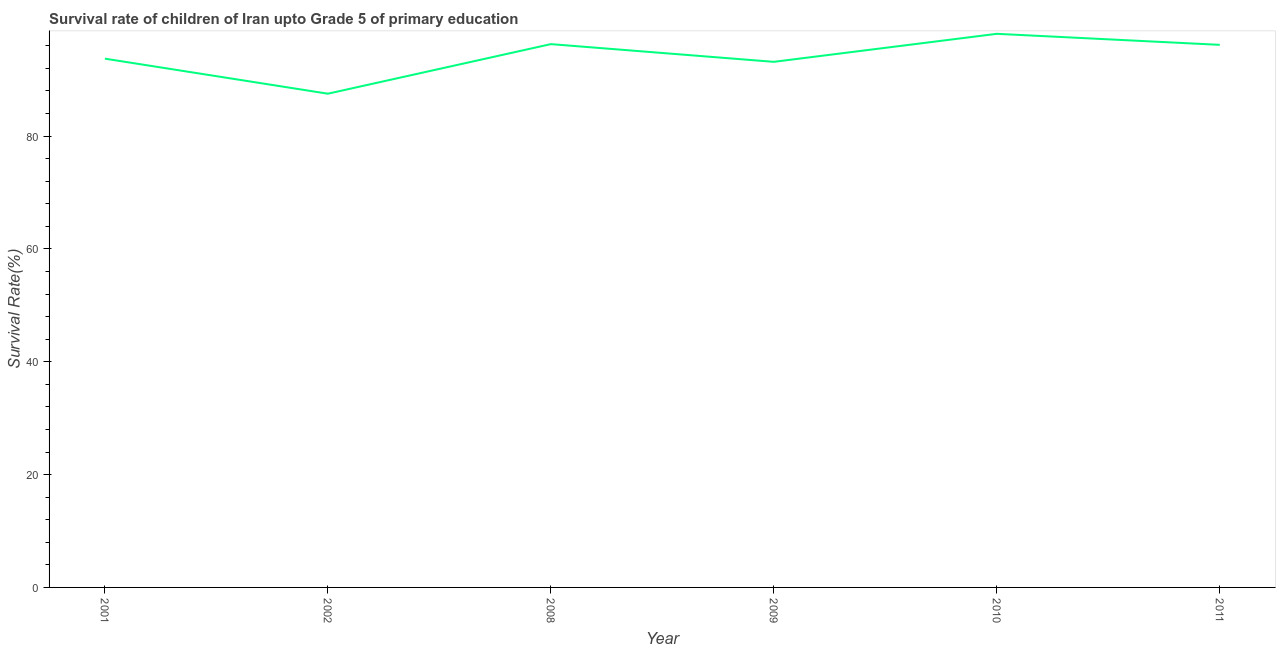What is the survival rate in 2009?
Your answer should be compact. 93.16. Across all years, what is the maximum survival rate?
Offer a terse response. 98.13. Across all years, what is the minimum survival rate?
Ensure brevity in your answer.  87.52. In which year was the survival rate maximum?
Offer a terse response. 2010. What is the sum of the survival rate?
Your answer should be compact. 565.02. What is the difference between the survival rate in 2008 and 2010?
Offer a very short reply. -1.83. What is the average survival rate per year?
Provide a succinct answer. 94.17. What is the median survival rate?
Offer a terse response. 94.95. Do a majority of the years between 2001 and 2008 (inclusive) have survival rate greater than 28 %?
Give a very brief answer. Yes. What is the ratio of the survival rate in 2008 to that in 2011?
Provide a succinct answer. 1. What is the difference between the highest and the second highest survival rate?
Your response must be concise. 1.83. Is the sum of the survival rate in 2009 and 2010 greater than the maximum survival rate across all years?
Make the answer very short. Yes. What is the difference between the highest and the lowest survival rate?
Offer a very short reply. 10.61. In how many years, is the survival rate greater than the average survival rate taken over all years?
Make the answer very short. 3. Does the survival rate monotonically increase over the years?
Give a very brief answer. No. How many lines are there?
Make the answer very short. 1. What is the difference between two consecutive major ticks on the Y-axis?
Your answer should be compact. 20. Are the values on the major ticks of Y-axis written in scientific E-notation?
Your answer should be very brief. No. Does the graph contain any zero values?
Keep it short and to the point. No. Does the graph contain grids?
Give a very brief answer. No. What is the title of the graph?
Offer a very short reply. Survival rate of children of Iran upto Grade 5 of primary education. What is the label or title of the Y-axis?
Your answer should be very brief. Survival Rate(%). What is the Survival Rate(%) of 2001?
Offer a terse response. 93.73. What is the Survival Rate(%) of 2002?
Ensure brevity in your answer.  87.52. What is the Survival Rate(%) in 2008?
Your response must be concise. 96.3. What is the Survival Rate(%) of 2009?
Offer a terse response. 93.16. What is the Survival Rate(%) of 2010?
Provide a succinct answer. 98.13. What is the Survival Rate(%) in 2011?
Your answer should be compact. 96.18. What is the difference between the Survival Rate(%) in 2001 and 2002?
Your answer should be very brief. 6.21. What is the difference between the Survival Rate(%) in 2001 and 2008?
Your answer should be very brief. -2.57. What is the difference between the Survival Rate(%) in 2001 and 2009?
Ensure brevity in your answer.  0.57. What is the difference between the Survival Rate(%) in 2001 and 2010?
Your answer should be compact. -4.4. What is the difference between the Survival Rate(%) in 2001 and 2011?
Offer a very short reply. -2.45. What is the difference between the Survival Rate(%) in 2002 and 2008?
Your answer should be compact. -8.79. What is the difference between the Survival Rate(%) in 2002 and 2009?
Your answer should be very brief. -5.65. What is the difference between the Survival Rate(%) in 2002 and 2010?
Your answer should be compact. -10.61. What is the difference between the Survival Rate(%) in 2002 and 2011?
Offer a very short reply. -8.66. What is the difference between the Survival Rate(%) in 2008 and 2009?
Your response must be concise. 3.14. What is the difference between the Survival Rate(%) in 2008 and 2010?
Offer a very short reply. -1.83. What is the difference between the Survival Rate(%) in 2008 and 2011?
Provide a short and direct response. 0.13. What is the difference between the Survival Rate(%) in 2009 and 2010?
Your response must be concise. -4.97. What is the difference between the Survival Rate(%) in 2009 and 2011?
Provide a succinct answer. -3.01. What is the difference between the Survival Rate(%) in 2010 and 2011?
Provide a succinct answer. 1.95. What is the ratio of the Survival Rate(%) in 2001 to that in 2002?
Keep it short and to the point. 1.07. What is the ratio of the Survival Rate(%) in 2001 to that in 2008?
Your answer should be very brief. 0.97. What is the ratio of the Survival Rate(%) in 2001 to that in 2010?
Offer a very short reply. 0.95. What is the ratio of the Survival Rate(%) in 2001 to that in 2011?
Provide a succinct answer. 0.97. What is the ratio of the Survival Rate(%) in 2002 to that in 2008?
Make the answer very short. 0.91. What is the ratio of the Survival Rate(%) in 2002 to that in 2009?
Provide a succinct answer. 0.94. What is the ratio of the Survival Rate(%) in 2002 to that in 2010?
Provide a succinct answer. 0.89. What is the ratio of the Survival Rate(%) in 2002 to that in 2011?
Keep it short and to the point. 0.91. What is the ratio of the Survival Rate(%) in 2008 to that in 2009?
Provide a succinct answer. 1.03. What is the ratio of the Survival Rate(%) in 2009 to that in 2010?
Make the answer very short. 0.95. What is the ratio of the Survival Rate(%) in 2010 to that in 2011?
Offer a very short reply. 1.02. 